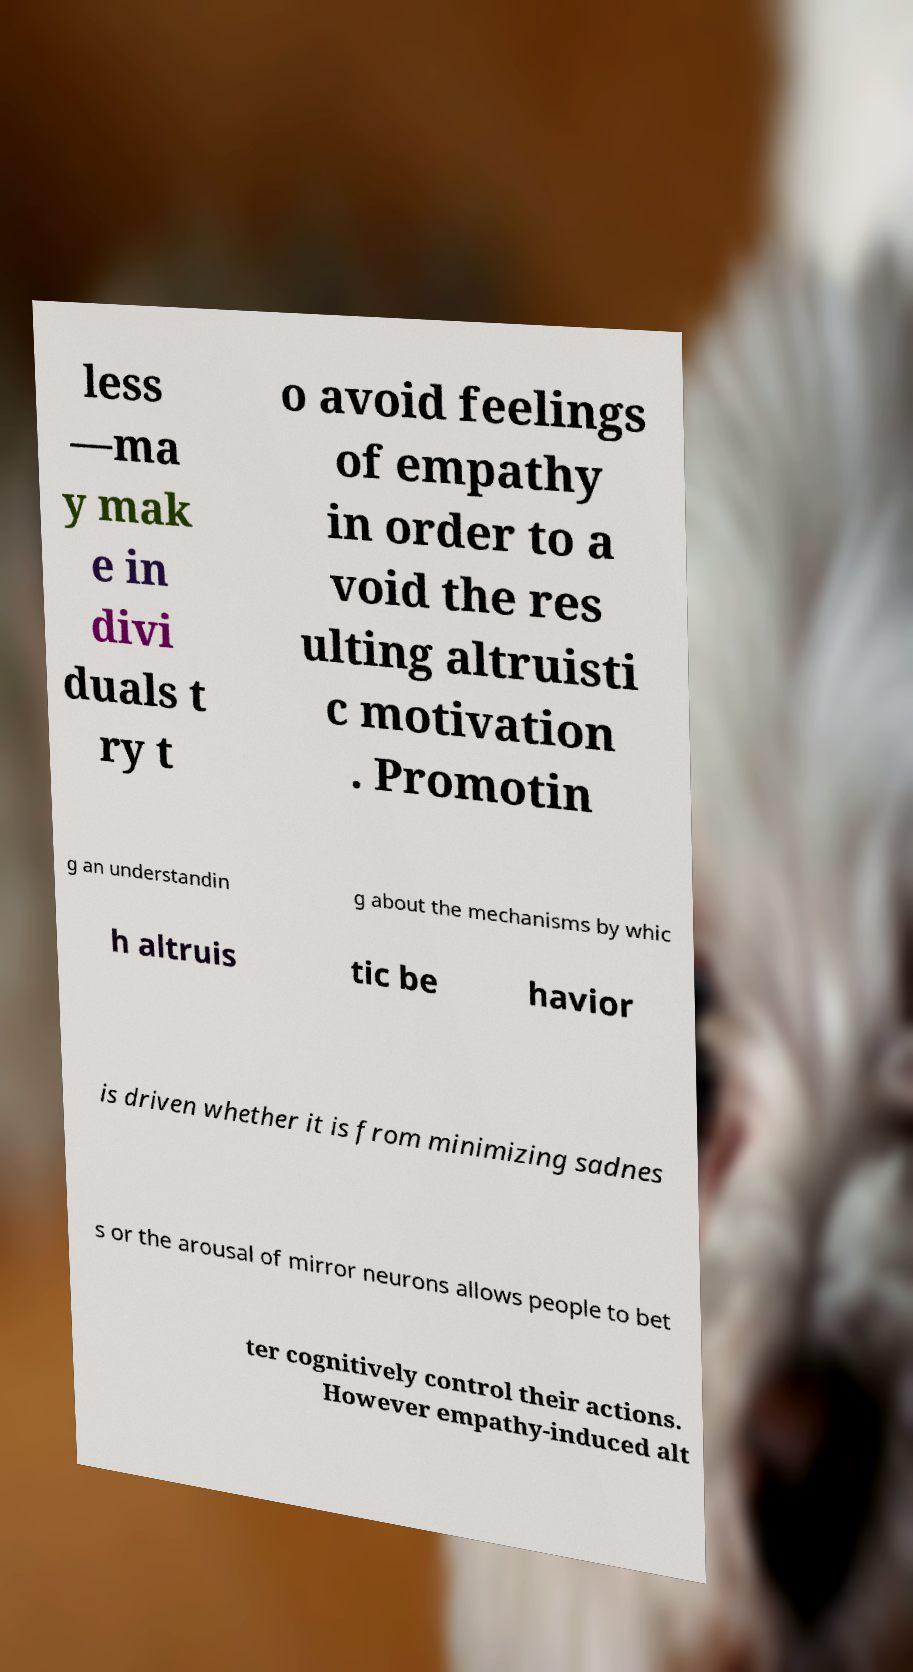Could you extract and type out the text from this image? less —ma y mak e in divi duals t ry t o avoid feelings of empathy in order to a void the res ulting altruisti c motivation . Promotin g an understandin g about the mechanisms by whic h altruis tic be havior is driven whether it is from minimizing sadnes s or the arousal of mirror neurons allows people to bet ter cognitively control their actions. However empathy-induced alt 